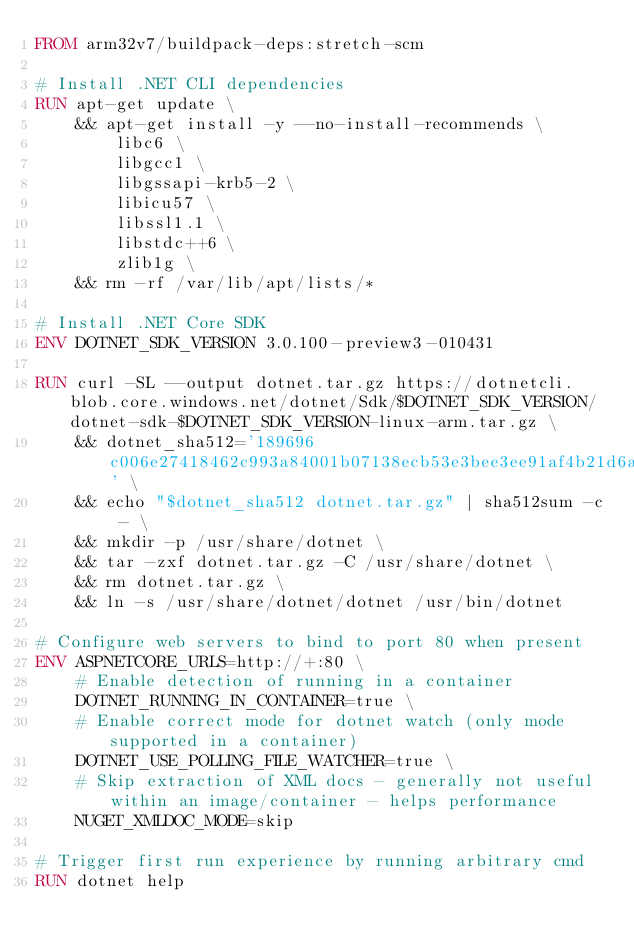<code> <loc_0><loc_0><loc_500><loc_500><_Dockerfile_>FROM arm32v7/buildpack-deps:stretch-scm

# Install .NET CLI dependencies
RUN apt-get update \
    && apt-get install -y --no-install-recommends \
        libc6 \
        libgcc1 \
        libgssapi-krb5-2 \
        libicu57 \
        libssl1.1 \
        libstdc++6 \
        zlib1g \
    && rm -rf /var/lib/apt/lists/*

# Install .NET Core SDK
ENV DOTNET_SDK_VERSION 3.0.100-preview3-010431

RUN curl -SL --output dotnet.tar.gz https://dotnetcli.blob.core.windows.net/dotnet/Sdk/$DOTNET_SDK_VERSION/dotnet-sdk-$DOTNET_SDK_VERSION-linux-arm.tar.gz \
    && dotnet_sha512='189696c006e27418462c993a84001b07138ecb53e3bee3ee91af4b21d6af88935b22fb3da67e705d4441cb4383765e99eb555f2b6556658002eda0f7d47e2391' \
    && echo "$dotnet_sha512 dotnet.tar.gz" | sha512sum -c - \
    && mkdir -p /usr/share/dotnet \
    && tar -zxf dotnet.tar.gz -C /usr/share/dotnet \
    && rm dotnet.tar.gz \
    && ln -s /usr/share/dotnet/dotnet /usr/bin/dotnet

# Configure web servers to bind to port 80 when present
ENV ASPNETCORE_URLS=http://+:80 \
    # Enable detection of running in a container
    DOTNET_RUNNING_IN_CONTAINER=true \
    # Enable correct mode for dotnet watch (only mode supported in a container)
    DOTNET_USE_POLLING_FILE_WATCHER=true \
    # Skip extraction of XML docs - generally not useful within an image/container - helps performance
    NUGET_XMLDOC_MODE=skip

# Trigger first run experience by running arbitrary cmd
RUN dotnet help
</code> 